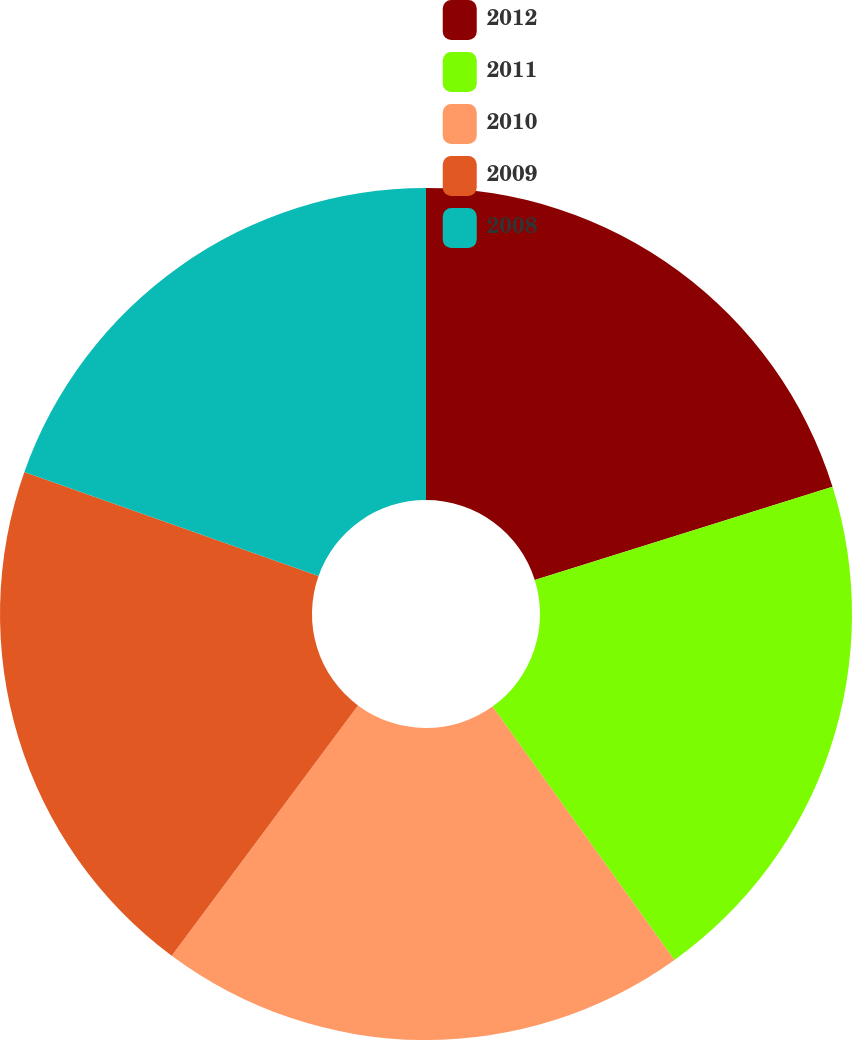Convert chart. <chart><loc_0><loc_0><loc_500><loc_500><pie_chart><fcel>2012<fcel>2011<fcel>2010<fcel>2009<fcel>2008<nl><fcel>20.17%<fcel>19.92%<fcel>20.09%<fcel>20.23%<fcel>19.59%<nl></chart> 